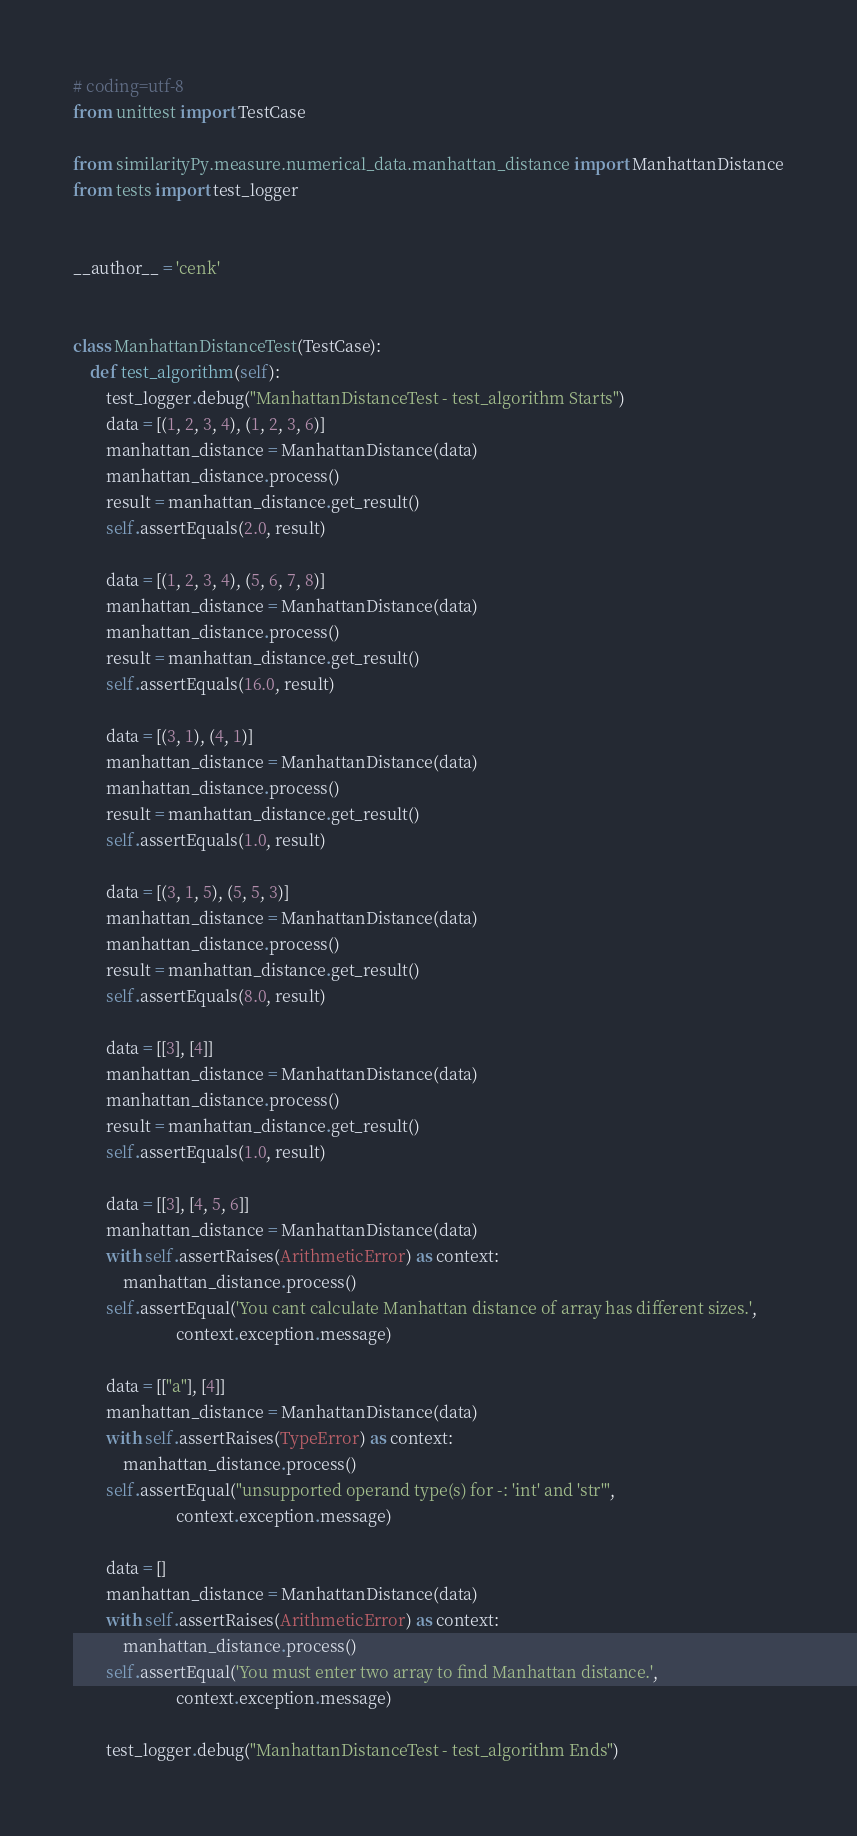<code> <loc_0><loc_0><loc_500><loc_500><_Python_># coding=utf-8
from unittest import TestCase

from similarityPy.measure.numerical_data.manhattan_distance import ManhattanDistance
from tests import test_logger


__author__ = 'cenk'


class ManhattanDistanceTest(TestCase):
    def test_algorithm(self):
        test_logger.debug("ManhattanDistanceTest - test_algorithm Starts")
        data = [(1, 2, 3, 4), (1, 2, 3, 6)]
        manhattan_distance = ManhattanDistance(data)
        manhattan_distance.process()
        result = manhattan_distance.get_result()
        self.assertEquals(2.0, result)

        data = [(1, 2, 3, 4), (5, 6, 7, 8)]
        manhattan_distance = ManhattanDistance(data)
        manhattan_distance.process()
        result = manhattan_distance.get_result()
        self.assertEquals(16.0, result)

        data = [(3, 1), (4, 1)]
        manhattan_distance = ManhattanDistance(data)
        manhattan_distance.process()
        result = manhattan_distance.get_result()
        self.assertEquals(1.0, result)

        data = [(3, 1, 5), (5, 5, 3)]
        manhattan_distance = ManhattanDistance(data)
        manhattan_distance.process()
        result = manhattan_distance.get_result()
        self.assertEquals(8.0, result)

        data = [[3], [4]]
        manhattan_distance = ManhattanDistance(data)
        manhattan_distance.process()
        result = manhattan_distance.get_result()
        self.assertEquals(1.0, result)

        data = [[3], [4, 5, 6]]
        manhattan_distance = ManhattanDistance(data)
        with self.assertRaises(ArithmeticError) as context:
            manhattan_distance.process()
        self.assertEqual('You cant calculate Manhattan distance of array has different sizes.',
                         context.exception.message)

        data = [["a"], [4]]
        manhattan_distance = ManhattanDistance(data)
        with self.assertRaises(TypeError) as context:
            manhattan_distance.process()
        self.assertEqual("unsupported operand type(s) for -: 'int' and 'str'",
                         context.exception.message)

        data = []
        manhattan_distance = ManhattanDistance(data)
        with self.assertRaises(ArithmeticError) as context:
            manhattan_distance.process()
        self.assertEqual('You must enter two array to find Manhattan distance.',
                         context.exception.message)

        test_logger.debug("ManhattanDistanceTest - test_algorithm Ends")</code> 